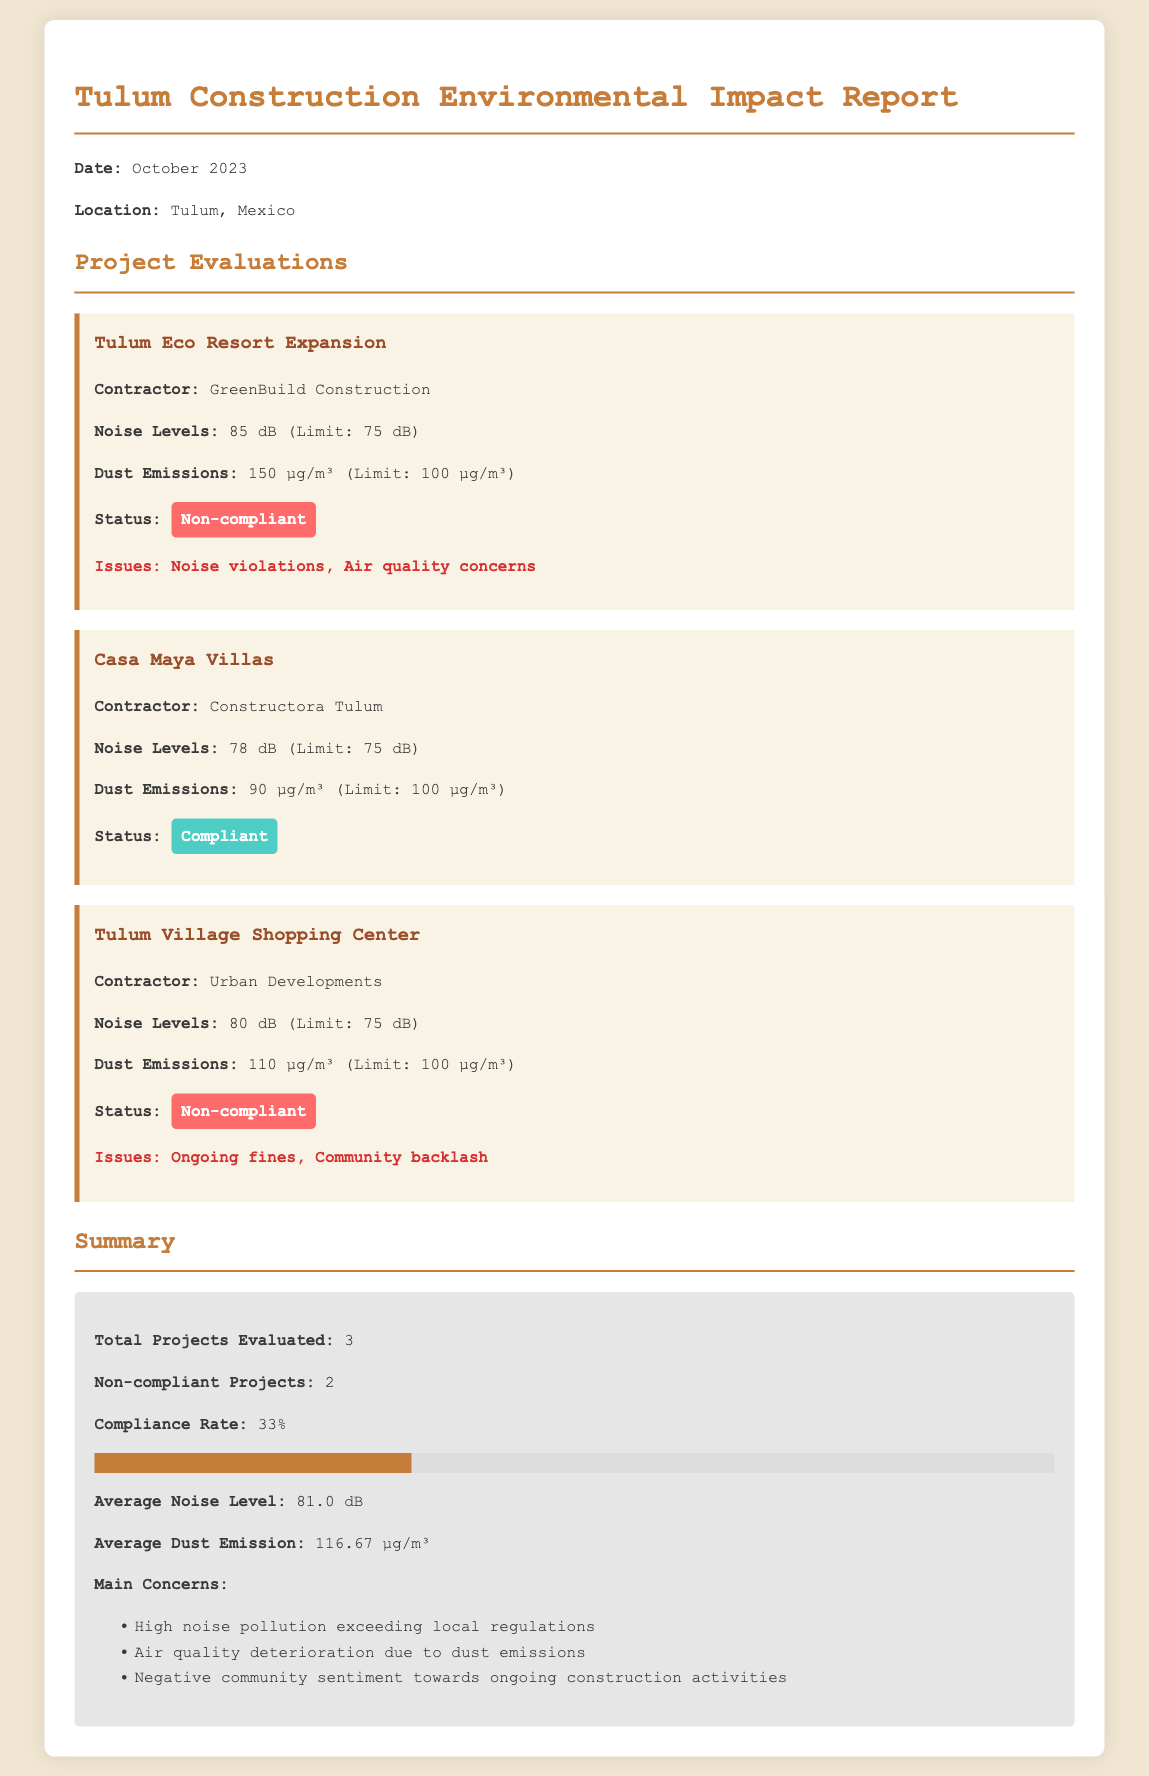What is the date of the report? The date of the report is mentioned at the beginning, which is October 2023.
Answer: October 2023 How many projects are evaluated? The total number of projects evaluated is stated in the summary section of the document.
Answer: 3 What is the compliance rate? The compliance rate is calculated based on the number of compliant projects and presented in the summary.
Answer: 33% Which project has the highest noise level? The noise levels for each project are given, with Tulum Eco Resort Expansion having the highest level at 85 dB.
Answer: Tulum Eco Resort Expansion What is the dust emission limit? The document explicitly states the dust emission limit alongside the measurements for each project.
Answer: 100 µg/m³ How many non-compliant projects are there? The total number of non-compliant projects is summarized in the report.
Answer: 2 What is the average dust emission? The report provides an average dust emission calculated from all evaluated projects.
Answer: 116.67 µg/m³ What issues are noted for the Tulum Village Shopping Center? The issues are outlined in the project evaluation section specifically for Tulum Village Shopping Center.
Answer: Ongoing fines, Community backlash What is the contractor for Casa Maya Villas? The contractor's name is mentioned directly in the project evaluation for Casa Maya Villas.
Answer: Constructora Tulum 